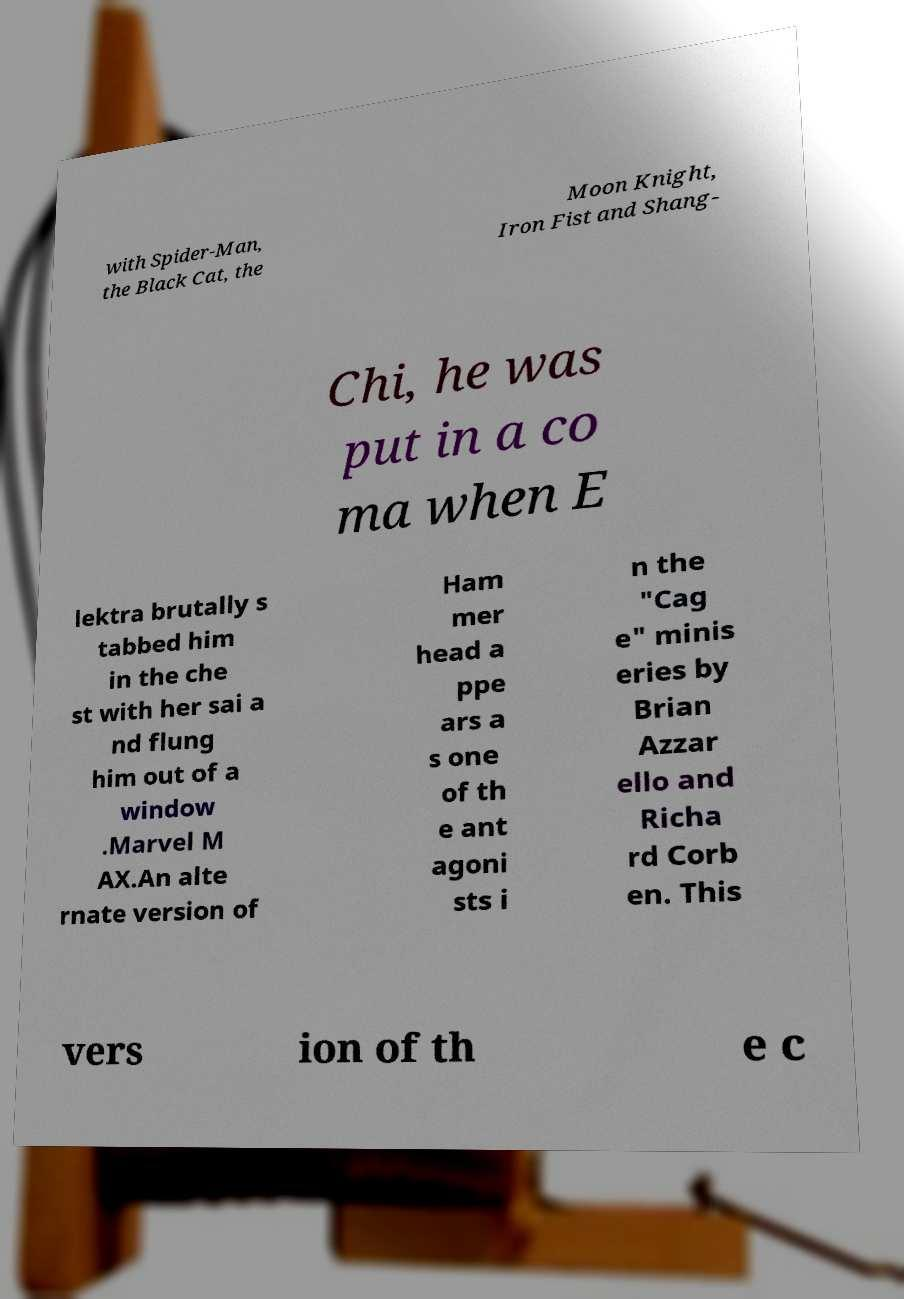I need the written content from this picture converted into text. Can you do that? with Spider-Man, the Black Cat, the Moon Knight, Iron Fist and Shang- Chi, he was put in a co ma when E lektra brutally s tabbed him in the che st with her sai a nd flung him out of a window .Marvel M AX.An alte rnate version of Ham mer head a ppe ars a s one of th e ant agoni sts i n the "Cag e" minis eries by Brian Azzar ello and Richa rd Corb en. This vers ion of th e c 